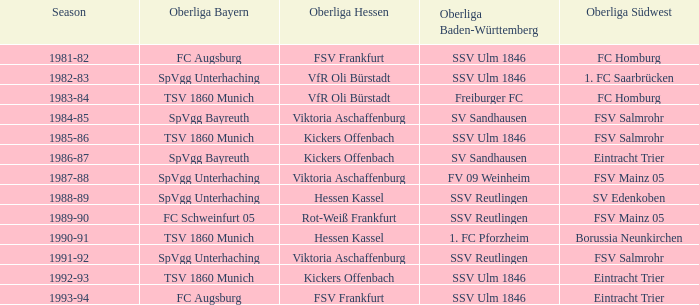Which oberliga baden-württemberg has a season of 1991-92? SSV Reutlingen. 